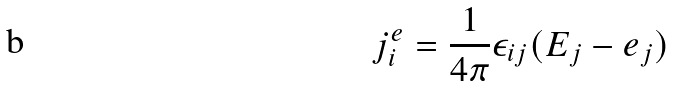<formula> <loc_0><loc_0><loc_500><loc_500>j ^ { e } _ { i } = \frac { 1 } { 4 \pi } { \epsilon } _ { i j } ( E _ { j } - e _ { j } )</formula> 